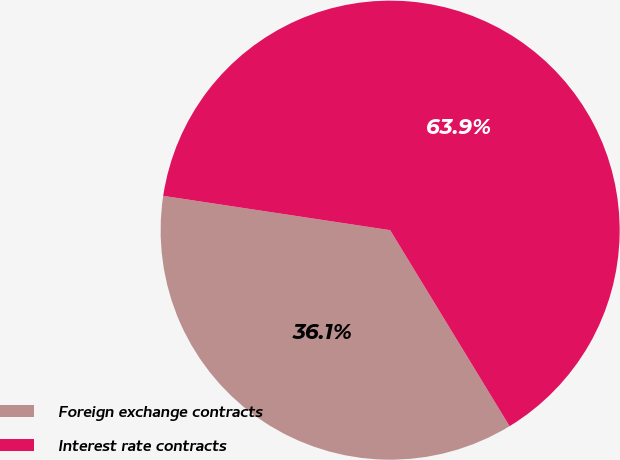Convert chart. <chart><loc_0><loc_0><loc_500><loc_500><pie_chart><fcel>Foreign exchange contracts<fcel>Interest rate contracts<nl><fcel>36.1%<fcel>63.9%<nl></chart> 